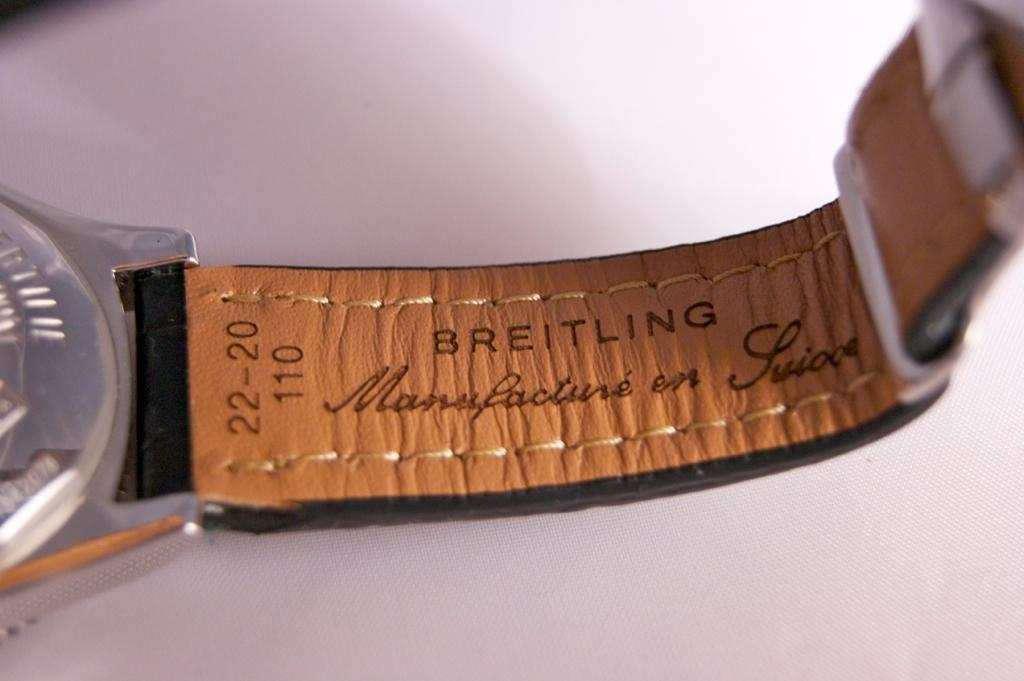<image>
Provide a brief description of the given image. A Breitling watch is laying on a table. 